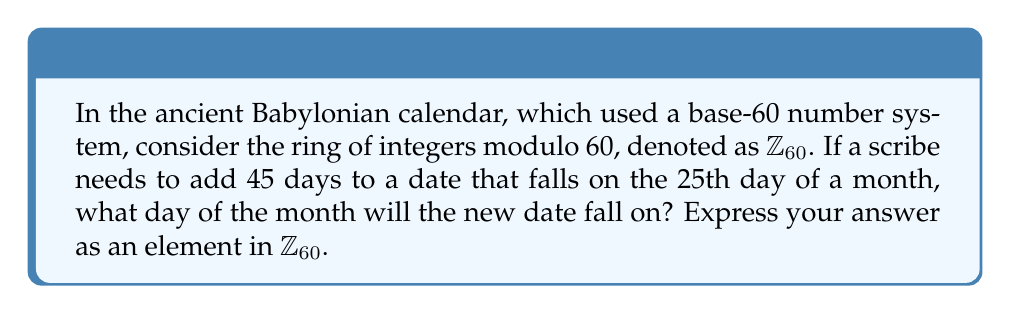Help me with this question. To solve this problem, we need to understand the concept of modular arithmetic in the context of the ancient Babylonian calendar:

1) The Babylonian calendar uses a base-60 system, which means we are working in the ring $\mathbb{Z}_{60}$.

2) In $\mathbb{Z}_{60}$, all numbers are equivalent to their remainder when divided by 60.

3) The problem asks us to add 45 days to the 25th day. In modular arithmetic, this is represented as:

   $$(25 + 45) \bmod 60$$

4) We can perform this addition:
   
   $$25 + 45 = 70$$

5) Now, we need to find the remainder when 70 is divided by 60:
   
   $$70 \div 60 = 1 \text{ remainder } 10$$

6) Therefore, in $\mathbb{Z}_{60}$, 70 is equivalent to 10.

This means that 45 days after the 25th day of a month, it will be the 10th day of a month in the Babylonian calendar.
Answer: $10 \in \mathbb{Z}_{60}$ 